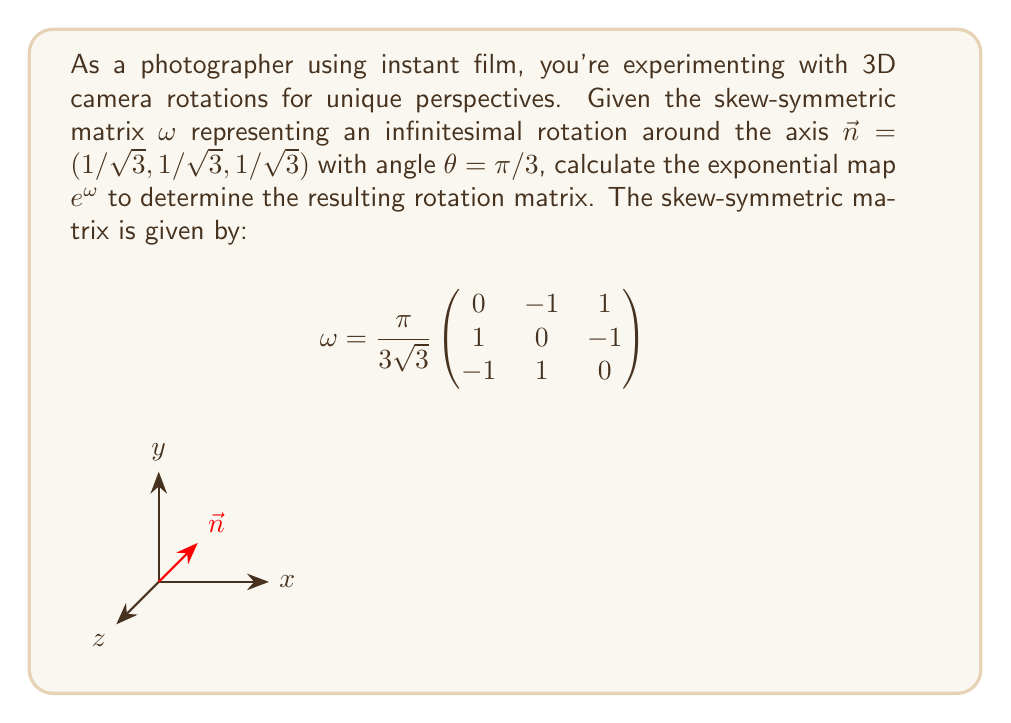Teach me how to tackle this problem. To calculate the exponential map for the rotation, we'll use Rodrigues' rotation formula:

$$e^{\omega} = I + \sin(\theta)\omega + (1-\cos(\theta))\omega^2$$

Where $I$ is the 3x3 identity matrix, $\theta$ is the rotation angle, and $\omega$ is the skew-symmetric matrix.

Step 1: Calculate $\omega^2$
$$\omega^2 = \left(\frac{\pi}{3\sqrt{3}}\right)^2
\begin{pmatrix}
-2 & 1 & 1 \\
1 & -2 & 1 \\
1 & 1 & -2
\end{pmatrix}$$

Step 2: Calculate $\sin(\theta)$ and $(1-\cos(\theta))$
$$\sin(\theta) = \sin(\pi/3) = \frac{\sqrt{3}}{2}$$
$$(1-\cos(\theta)) = (1-\cos(\pi/3)) = 1 - \frac{1}{2} = \frac{1}{2}$$

Step 3: Substitute values into Rodrigues' formula
$$e^{\omega} = I + \frac{\sqrt{3}}{2}\cdot\frac{\pi}{3\sqrt{3}}
\begin{pmatrix}
0 & -1 & 1 \\
1 & 0 & -1 \\
-1 & 1 & 0
\end{pmatrix} + \frac{1}{2}\cdot\left(\frac{\pi}{3\sqrt{3}}\right)^2
\begin{pmatrix}
-2 & 1 & 1 \\
1 & -2 & 1 \\
1 & 1 & -2
\end{pmatrix}$$

Step 4: Simplify and compute the final rotation matrix
$$e^{\omega} = 
\begin{pmatrix}
1 & 0 & 0 \\
0 & 1 & 0 \\
0 & 0 & 1
\end{pmatrix} + 
\frac{\pi}{6}
\begin{pmatrix}
0 & -1 & 1 \\
1 & 0 & -1 \\
-1 & 1 & 0
\end{pmatrix} + 
\frac{\pi^2}{54}
\begin{pmatrix}
-2 & 1 & 1 \\
1 & -2 & 1 \\
1 & 1 & -2
\end{pmatrix}$$

Combining these terms yields the final rotation matrix.
Answer: $$e^{\omega} = 
\begin{pmatrix}
\frac{2}{3} & -\frac{2\sqrt{3}-3}{6} & \frac{2\sqrt{3}+3}{6} \\
\frac{2\sqrt{3}+3}{6} & \frac{2}{3} & -\frac{2\sqrt{3}-3}{6} \\
-\frac{2\sqrt{3}-3}{6} & \frac{2\sqrt{3}+3}{6} & \frac{2}{3}
\end{pmatrix}$$ 